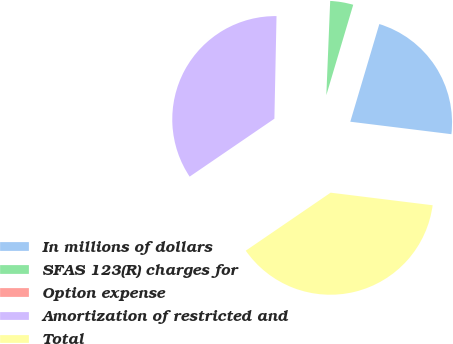Convert chart. <chart><loc_0><loc_0><loc_500><loc_500><pie_chart><fcel>In millions of dollars<fcel>SFAS 123(R) charges for<fcel>Option expense<fcel>Amortization of restricted and<fcel>Total<nl><fcel>22.35%<fcel>3.95%<fcel>0.32%<fcel>34.87%<fcel>38.5%<nl></chart> 